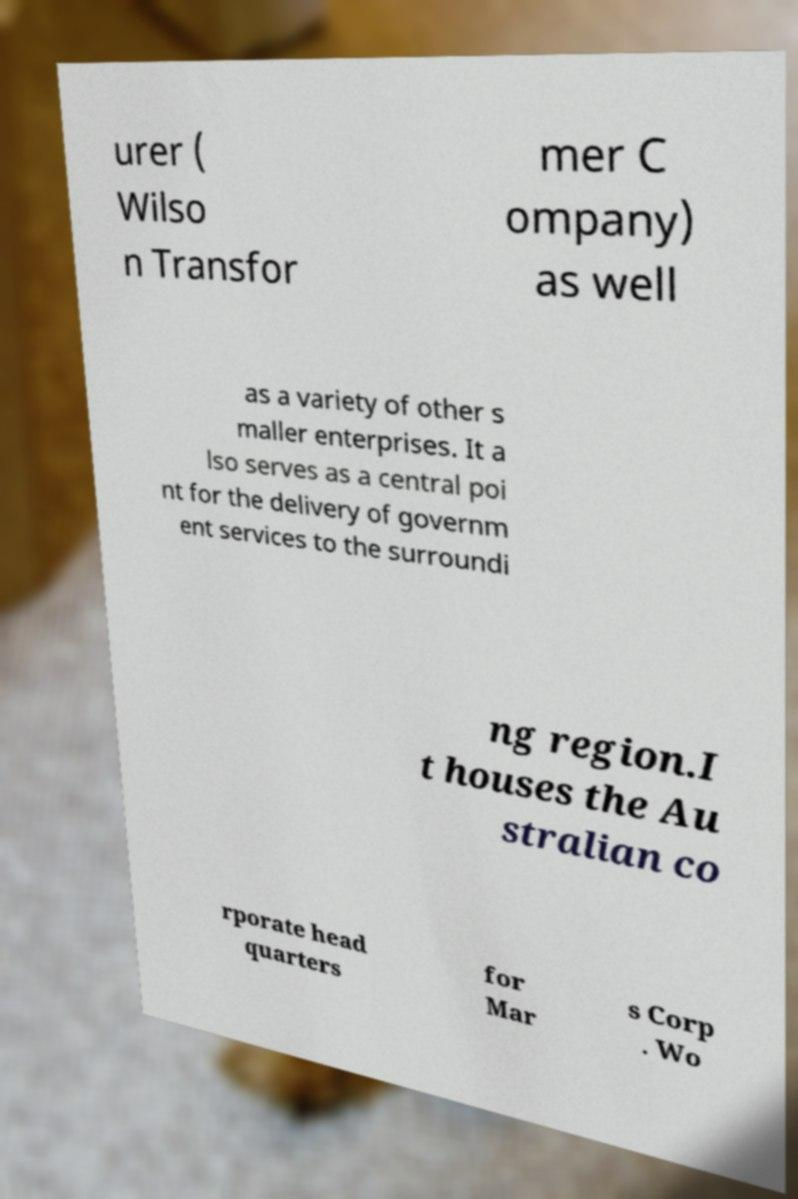I need the written content from this picture converted into text. Can you do that? urer ( Wilso n Transfor mer C ompany) as well as a variety of other s maller enterprises. It a lso serves as a central poi nt for the delivery of governm ent services to the surroundi ng region.I t houses the Au stralian co rporate head quarters for Mar s Corp . Wo 